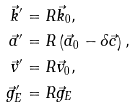<formula> <loc_0><loc_0><loc_500><loc_500>\vec { k } ^ { \prime } & = R \vec { k } _ { 0 } , \\ \vec { a } ^ { \prime } & = R \left ( \vec { a } _ { 0 } - \delta \vec { c } \right ) , \\ \vec { v } ^ { \prime } & = R \vec { v } _ { 0 } , \\ \vec { g } _ { E } ^ { \prime } & = R \vec { g } _ { E }</formula> 